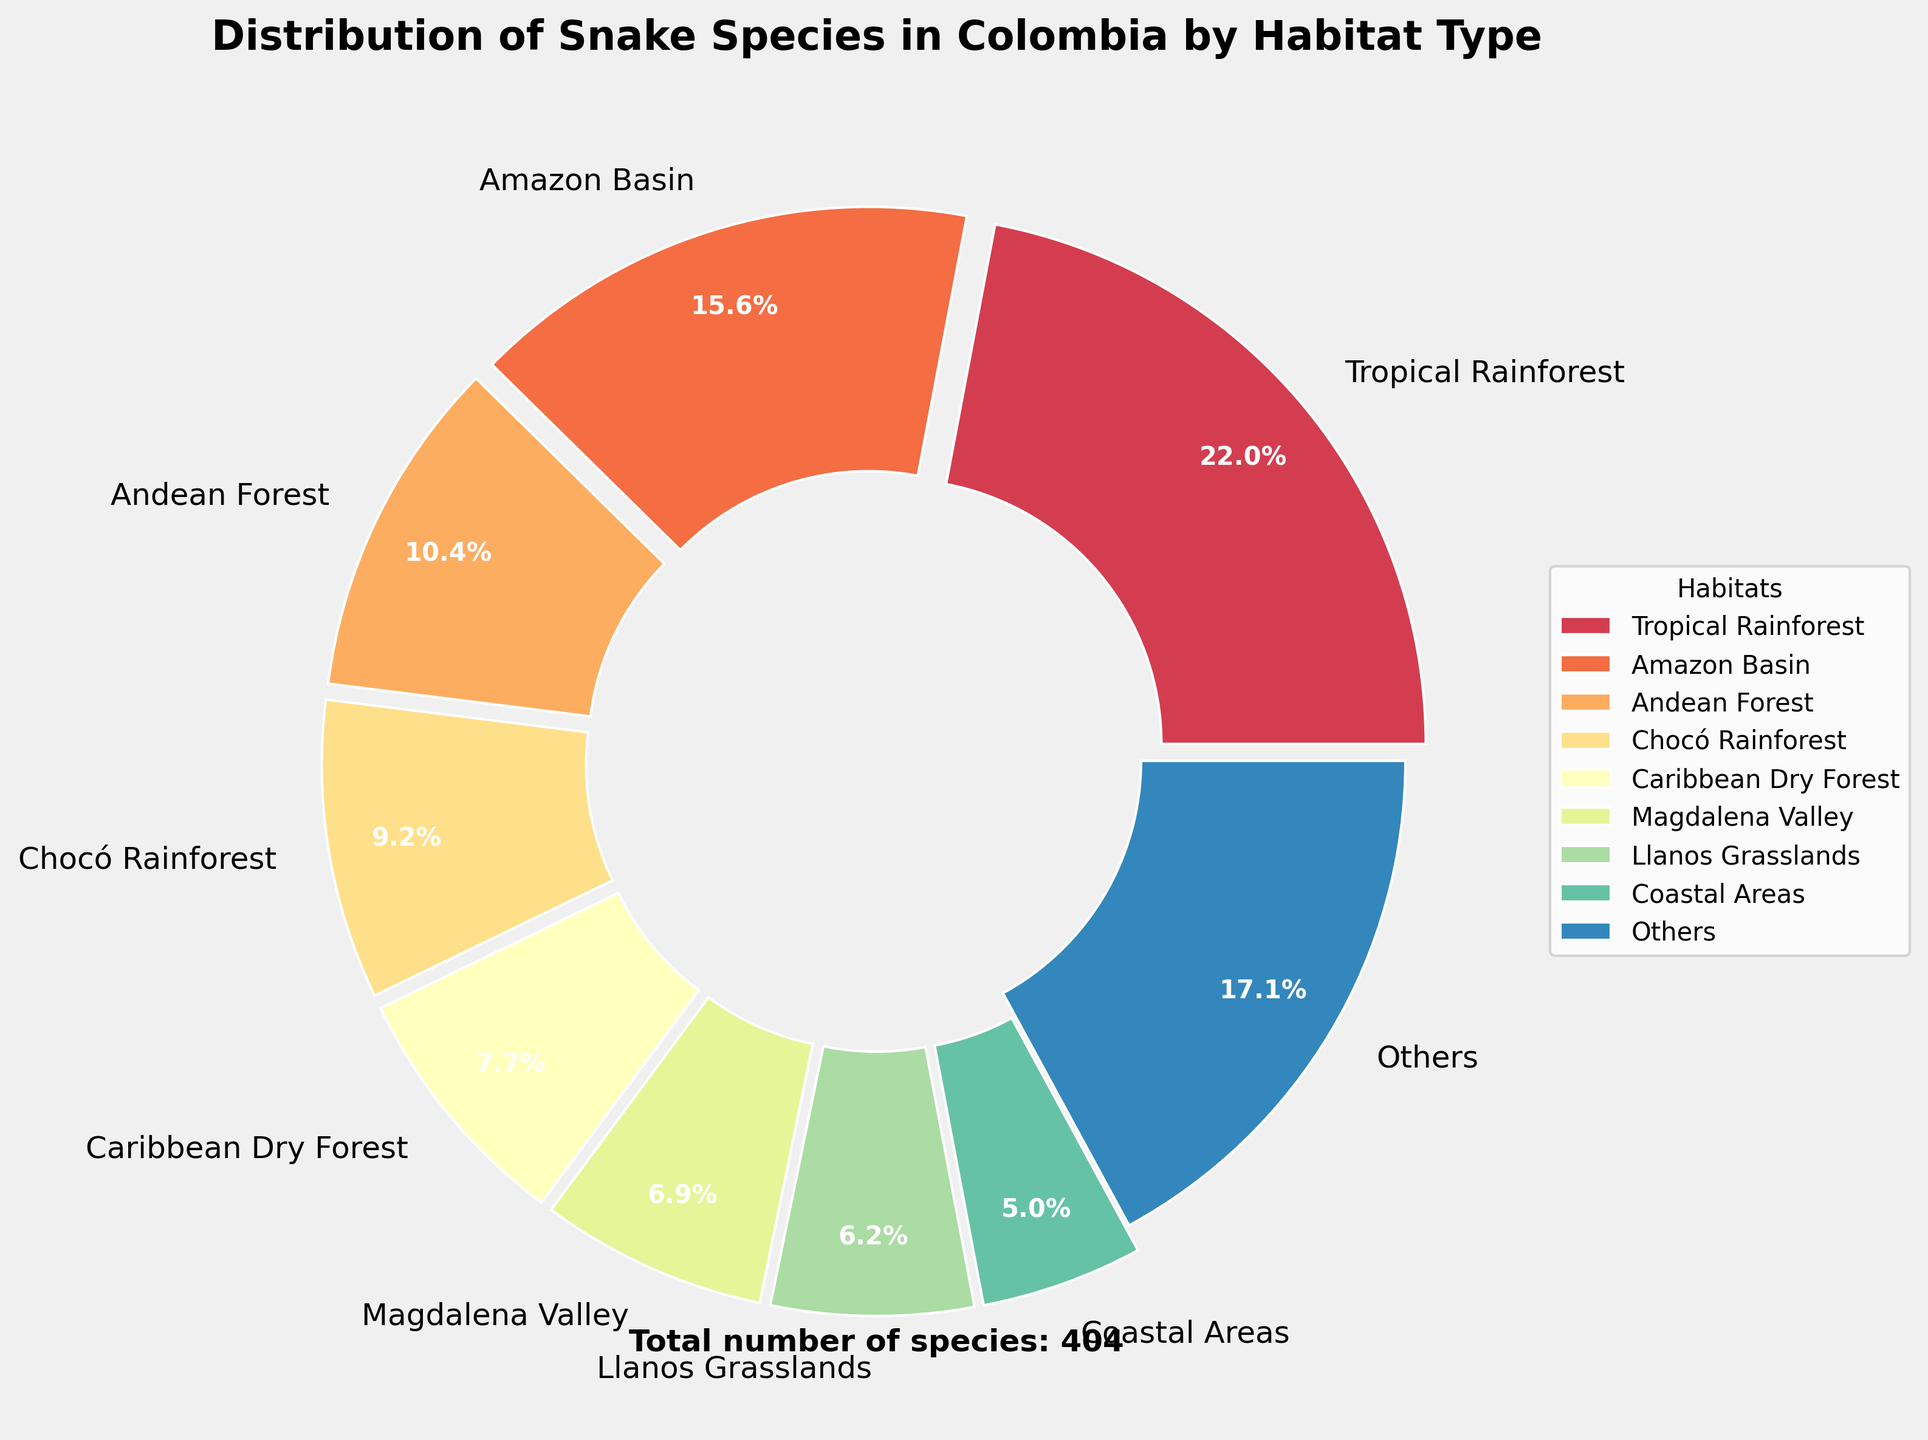What habitat type hosts the highest percentage of snake species in Colombia? By examining the pie chart, the habitat with the largest slice is identified as having the highest percentage. The "Tropical Rainforest" dominates the chart with the largest slice labeled at 26.8%.
Answer: Tropical Rainforest What is the combined percentage of snake species found in Andean Forest and Caribbean Dry Forest? From the pie chart, find the percentage values for "Andean Forest" and "Caribbean Dry Forest". The values are 12.7% and 9.4%, respectively. Adding these together, 12.7% + 9.4% = 22.1%.
Answer: 22.1% Which has more snake species, Amazon Basin or Chocó Rainforest? Compare the percentage slices for "Amazon Basin" and "Chocó Rainforest". The chart shows Amazon Basin at 19% and Chocó Rainforest at 11.2%. Therefore, Amazon Basin has more.
Answer: Amazon Basin How does the number of snake species in Coastal Areas compare to those in Cloud Forest? Look at the slices for "Coastal Areas" and "Cloud Forest". Coastal Areas have 6.0% and Cloud Forest has 5.5%. Therefore, Coastal Areas have a slightly higher percentage.
Answer: Coastal Areas What is the total percentage of snake species found in the top 3 habitat types? Identify the top 3 largest slices from the pie chart, which are "Tropical Rainforest" (26.8%), "Amazon Basin" (19%), and "Andean Forest" (12.7%). Summing these up, 26.8% + 19% + 12.7% = 58.5%.
Answer: 58.5% What visual cue is used to distinguish the "Others" category in the pie chart? The visual cue for the "Others" category is that its slice is not exploded compared to the other slices that have a small gap from the center. Additionally, "Others" is typically located last in the legend.
Answer: Not exploded Are there any habitats with less than 2% representation in the chart? By observing the pie chart, if any slices are small or labeled with a percentage smaller than 2%. However, since the 'Others' category includes all those with lower percentages, it aggregates any potential habitats with less than 2%.
Answer: No If you remove the top habitat type (Tropical Rainforest), what would be the new percentage for the next largest habitat (Amazon Basin)? The percentage for Amazon Basin is already known as 19%. The top percentage slice (Tropical Rainforest) is removed. The new total percentage would be recalculated as follows: (100% - 26.8%) = 73.2%; hence, (19/73.2)*100 ≈ 25.9%.
Answer: 25.9% What is the percentage share of the habitats grouped as "Others"? The "Others" slice in the pie chart represents the combined percentages of all habitats outside the top 8. This value is calculated and displayed directly within the chart as 12.7%.
Answer: 12.7% How much larger is the Tropical Rainforest percentage compared to the Guajira Desert? Subtract the percentage of Guajira Desert (2.7%) from the percentage of Tropical Rainforest (26.8%). The difference is 26.8% - 2.7% = 24.1%.
Answer: 24.1% 